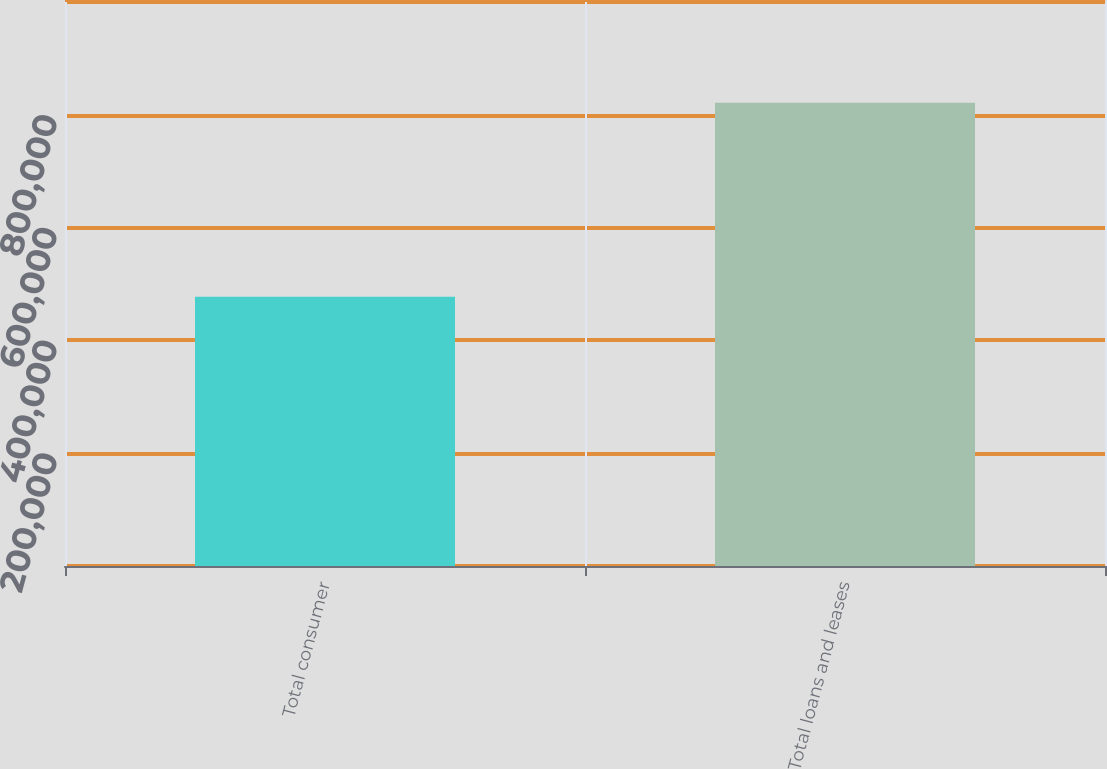Convert chart. <chart><loc_0><loc_0><loc_500><loc_500><bar_chart><fcel>Total consumer<fcel>Total loans and leases<nl><fcel>477607<fcel>821150<nl></chart> 